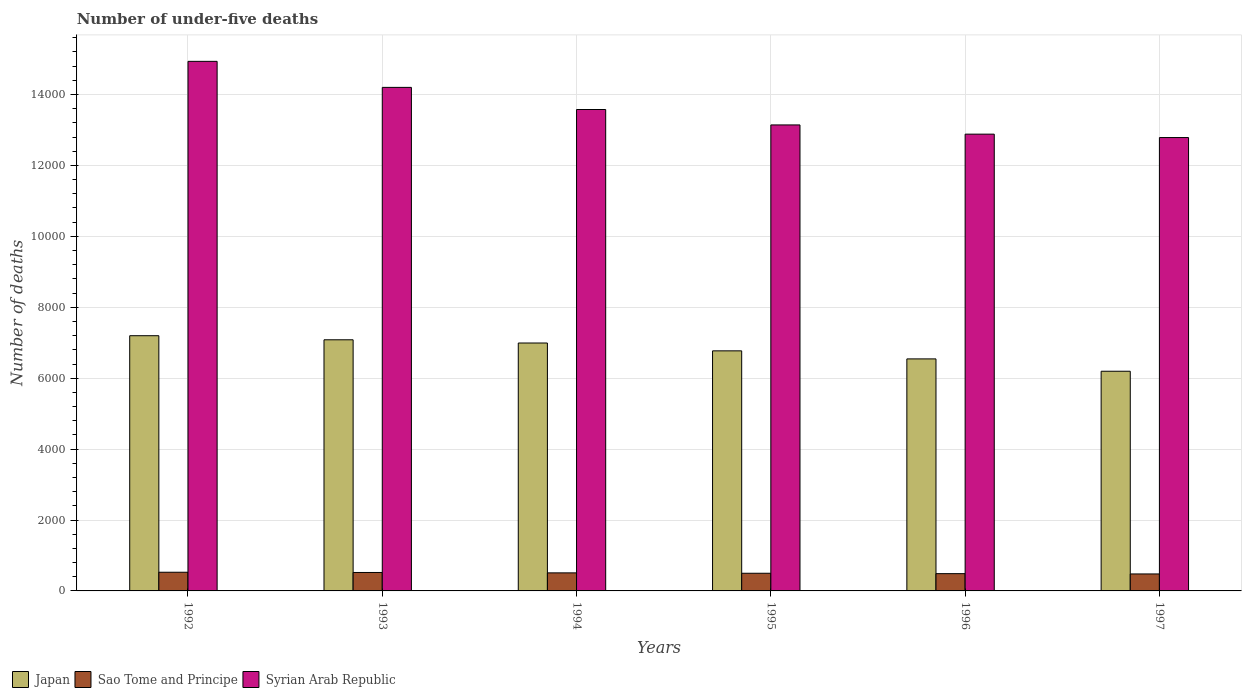Are the number of bars per tick equal to the number of legend labels?
Keep it short and to the point. Yes. Are the number of bars on each tick of the X-axis equal?
Your answer should be compact. Yes. What is the label of the 4th group of bars from the left?
Your answer should be compact. 1995. In how many cases, is the number of bars for a given year not equal to the number of legend labels?
Offer a very short reply. 0. What is the number of under-five deaths in Syrian Arab Republic in 1994?
Your answer should be compact. 1.36e+04. Across all years, what is the maximum number of under-five deaths in Japan?
Your answer should be compact. 7198. Across all years, what is the minimum number of under-five deaths in Syrian Arab Republic?
Provide a succinct answer. 1.28e+04. In which year was the number of under-five deaths in Syrian Arab Republic maximum?
Offer a terse response. 1992. What is the total number of under-five deaths in Sao Tome and Principe in the graph?
Give a very brief answer. 3020. What is the difference between the number of under-five deaths in Japan in 1992 and the number of under-five deaths in Syrian Arab Republic in 1996?
Keep it short and to the point. -5685. What is the average number of under-five deaths in Japan per year?
Give a very brief answer. 6797.33. In the year 1995, what is the difference between the number of under-five deaths in Sao Tome and Principe and number of under-five deaths in Japan?
Keep it short and to the point. -6273. In how many years, is the number of under-five deaths in Syrian Arab Republic greater than 14800?
Ensure brevity in your answer.  1. What is the ratio of the number of under-five deaths in Japan in 1992 to that in 1993?
Your answer should be very brief. 1.02. Is the difference between the number of under-five deaths in Sao Tome and Principe in 1994 and 1995 greater than the difference between the number of under-five deaths in Japan in 1994 and 1995?
Provide a short and direct response. No. What is the difference between the highest and the second highest number of under-five deaths in Syrian Arab Republic?
Your answer should be very brief. 734. What is the difference between the highest and the lowest number of under-five deaths in Syrian Arab Republic?
Give a very brief answer. 2149. In how many years, is the number of under-five deaths in Japan greater than the average number of under-five deaths in Japan taken over all years?
Offer a very short reply. 3. What does the 2nd bar from the left in 1995 represents?
Your answer should be very brief. Sao Tome and Principe. What does the 1st bar from the right in 1993 represents?
Your answer should be very brief. Syrian Arab Republic. What is the difference between two consecutive major ticks on the Y-axis?
Provide a succinct answer. 2000. Are the values on the major ticks of Y-axis written in scientific E-notation?
Keep it short and to the point. No. Does the graph contain any zero values?
Your answer should be very brief. No. Where does the legend appear in the graph?
Make the answer very short. Bottom left. How many legend labels are there?
Your answer should be compact. 3. How are the legend labels stacked?
Give a very brief answer. Horizontal. What is the title of the graph?
Your answer should be very brief. Number of under-five deaths. What is the label or title of the X-axis?
Provide a succinct answer. Years. What is the label or title of the Y-axis?
Your response must be concise. Number of deaths. What is the Number of deaths of Japan in 1992?
Give a very brief answer. 7198. What is the Number of deaths of Sao Tome and Principe in 1992?
Make the answer very short. 527. What is the Number of deaths in Syrian Arab Republic in 1992?
Provide a short and direct response. 1.49e+04. What is the Number of deaths of Japan in 1993?
Ensure brevity in your answer.  7083. What is the Number of deaths in Sao Tome and Principe in 1993?
Offer a terse response. 520. What is the Number of deaths of Syrian Arab Republic in 1993?
Offer a very short reply. 1.42e+04. What is the Number of deaths of Japan in 1994?
Your answer should be very brief. 6992. What is the Number of deaths of Sao Tome and Principe in 1994?
Ensure brevity in your answer.  509. What is the Number of deaths in Syrian Arab Republic in 1994?
Keep it short and to the point. 1.36e+04. What is the Number of deaths in Japan in 1995?
Provide a short and direct response. 6771. What is the Number of deaths in Sao Tome and Principe in 1995?
Your answer should be compact. 498. What is the Number of deaths of Syrian Arab Republic in 1995?
Provide a short and direct response. 1.31e+04. What is the Number of deaths in Japan in 1996?
Your answer should be very brief. 6544. What is the Number of deaths of Sao Tome and Principe in 1996?
Make the answer very short. 487. What is the Number of deaths of Syrian Arab Republic in 1996?
Offer a very short reply. 1.29e+04. What is the Number of deaths in Japan in 1997?
Keep it short and to the point. 6196. What is the Number of deaths of Sao Tome and Principe in 1997?
Keep it short and to the point. 479. What is the Number of deaths in Syrian Arab Republic in 1997?
Give a very brief answer. 1.28e+04. Across all years, what is the maximum Number of deaths of Japan?
Offer a terse response. 7198. Across all years, what is the maximum Number of deaths of Sao Tome and Principe?
Offer a very short reply. 527. Across all years, what is the maximum Number of deaths of Syrian Arab Republic?
Provide a succinct answer. 1.49e+04. Across all years, what is the minimum Number of deaths in Japan?
Ensure brevity in your answer.  6196. Across all years, what is the minimum Number of deaths of Sao Tome and Principe?
Offer a very short reply. 479. Across all years, what is the minimum Number of deaths of Syrian Arab Republic?
Keep it short and to the point. 1.28e+04. What is the total Number of deaths of Japan in the graph?
Your answer should be compact. 4.08e+04. What is the total Number of deaths of Sao Tome and Principe in the graph?
Offer a very short reply. 3020. What is the total Number of deaths of Syrian Arab Republic in the graph?
Provide a succinct answer. 8.15e+04. What is the difference between the Number of deaths in Japan in 1992 and that in 1993?
Your response must be concise. 115. What is the difference between the Number of deaths in Syrian Arab Republic in 1992 and that in 1993?
Keep it short and to the point. 734. What is the difference between the Number of deaths of Japan in 1992 and that in 1994?
Your answer should be very brief. 206. What is the difference between the Number of deaths of Syrian Arab Republic in 1992 and that in 1994?
Your response must be concise. 1358. What is the difference between the Number of deaths of Japan in 1992 and that in 1995?
Offer a very short reply. 427. What is the difference between the Number of deaths of Syrian Arab Republic in 1992 and that in 1995?
Ensure brevity in your answer.  1793. What is the difference between the Number of deaths in Japan in 1992 and that in 1996?
Offer a terse response. 654. What is the difference between the Number of deaths in Sao Tome and Principe in 1992 and that in 1996?
Keep it short and to the point. 40. What is the difference between the Number of deaths of Syrian Arab Republic in 1992 and that in 1996?
Your answer should be compact. 2053. What is the difference between the Number of deaths of Japan in 1992 and that in 1997?
Make the answer very short. 1002. What is the difference between the Number of deaths of Syrian Arab Republic in 1992 and that in 1997?
Offer a very short reply. 2149. What is the difference between the Number of deaths in Japan in 1993 and that in 1994?
Provide a succinct answer. 91. What is the difference between the Number of deaths of Sao Tome and Principe in 1993 and that in 1994?
Provide a succinct answer. 11. What is the difference between the Number of deaths of Syrian Arab Republic in 1993 and that in 1994?
Ensure brevity in your answer.  624. What is the difference between the Number of deaths of Japan in 1993 and that in 1995?
Your response must be concise. 312. What is the difference between the Number of deaths in Syrian Arab Republic in 1993 and that in 1995?
Offer a terse response. 1059. What is the difference between the Number of deaths of Japan in 1993 and that in 1996?
Give a very brief answer. 539. What is the difference between the Number of deaths in Sao Tome and Principe in 1993 and that in 1996?
Make the answer very short. 33. What is the difference between the Number of deaths in Syrian Arab Republic in 1993 and that in 1996?
Provide a succinct answer. 1319. What is the difference between the Number of deaths of Japan in 1993 and that in 1997?
Offer a terse response. 887. What is the difference between the Number of deaths of Sao Tome and Principe in 1993 and that in 1997?
Offer a very short reply. 41. What is the difference between the Number of deaths of Syrian Arab Republic in 1993 and that in 1997?
Keep it short and to the point. 1415. What is the difference between the Number of deaths in Japan in 1994 and that in 1995?
Make the answer very short. 221. What is the difference between the Number of deaths of Sao Tome and Principe in 1994 and that in 1995?
Give a very brief answer. 11. What is the difference between the Number of deaths of Syrian Arab Republic in 1994 and that in 1995?
Provide a short and direct response. 435. What is the difference between the Number of deaths of Japan in 1994 and that in 1996?
Your response must be concise. 448. What is the difference between the Number of deaths of Sao Tome and Principe in 1994 and that in 1996?
Provide a succinct answer. 22. What is the difference between the Number of deaths of Syrian Arab Republic in 1994 and that in 1996?
Give a very brief answer. 695. What is the difference between the Number of deaths in Japan in 1994 and that in 1997?
Give a very brief answer. 796. What is the difference between the Number of deaths of Syrian Arab Republic in 1994 and that in 1997?
Your response must be concise. 791. What is the difference between the Number of deaths in Japan in 1995 and that in 1996?
Your answer should be compact. 227. What is the difference between the Number of deaths of Sao Tome and Principe in 1995 and that in 1996?
Give a very brief answer. 11. What is the difference between the Number of deaths in Syrian Arab Republic in 1995 and that in 1996?
Your answer should be compact. 260. What is the difference between the Number of deaths of Japan in 1995 and that in 1997?
Keep it short and to the point. 575. What is the difference between the Number of deaths of Sao Tome and Principe in 1995 and that in 1997?
Your answer should be very brief. 19. What is the difference between the Number of deaths in Syrian Arab Republic in 1995 and that in 1997?
Keep it short and to the point. 356. What is the difference between the Number of deaths in Japan in 1996 and that in 1997?
Your answer should be very brief. 348. What is the difference between the Number of deaths of Sao Tome and Principe in 1996 and that in 1997?
Ensure brevity in your answer.  8. What is the difference between the Number of deaths of Syrian Arab Republic in 1996 and that in 1997?
Provide a succinct answer. 96. What is the difference between the Number of deaths of Japan in 1992 and the Number of deaths of Sao Tome and Principe in 1993?
Offer a very short reply. 6678. What is the difference between the Number of deaths in Japan in 1992 and the Number of deaths in Syrian Arab Republic in 1993?
Ensure brevity in your answer.  -7004. What is the difference between the Number of deaths in Sao Tome and Principe in 1992 and the Number of deaths in Syrian Arab Republic in 1993?
Provide a succinct answer. -1.37e+04. What is the difference between the Number of deaths in Japan in 1992 and the Number of deaths in Sao Tome and Principe in 1994?
Offer a very short reply. 6689. What is the difference between the Number of deaths in Japan in 1992 and the Number of deaths in Syrian Arab Republic in 1994?
Keep it short and to the point. -6380. What is the difference between the Number of deaths in Sao Tome and Principe in 1992 and the Number of deaths in Syrian Arab Republic in 1994?
Offer a very short reply. -1.31e+04. What is the difference between the Number of deaths in Japan in 1992 and the Number of deaths in Sao Tome and Principe in 1995?
Provide a succinct answer. 6700. What is the difference between the Number of deaths in Japan in 1992 and the Number of deaths in Syrian Arab Republic in 1995?
Provide a short and direct response. -5945. What is the difference between the Number of deaths of Sao Tome and Principe in 1992 and the Number of deaths of Syrian Arab Republic in 1995?
Your answer should be very brief. -1.26e+04. What is the difference between the Number of deaths in Japan in 1992 and the Number of deaths in Sao Tome and Principe in 1996?
Your response must be concise. 6711. What is the difference between the Number of deaths of Japan in 1992 and the Number of deaths of Syrian Arab Republic in 1996?
Provide a succinct answer. -5685. What is the difference between the Number of deaths in Sao Tome and Principe in 1992 and the Number of deaths in Syrian Arab Republic in 1996?
Ensure brevity in your answer.  -1.24e+04. What is the difference between the Number of deaths of Japan in 1992 and the Number of deaths of Sao Tome and Principe in 1997?
Your answer should be compact. 6719. What is the difference between the Number of deaths in Japan in 1992 and the Number of deaths in Syrian Arab Republic in 1997?
Keep it short and to the point. -5589. What is the difference between the Number of deaths in Sao Tome and Principe in 1992 and the Number of deaths in Syrian Arab Republic in 1997?
Provide a succinct answer. -1.23e+04. What is the difference between the Number of deaths in Japan in 1993 and the Number of deaths in Sao Tome and Principe in 1994?
Provide a succinct answer. 6574. What is the difference between the Number of deaths of Japan in 1993 and the Number of deaths of Syrian Arab Republic in 1994?
Make the answer very short. -6495. What is the difference between the Number of deaths in Sao Tome and Principe in 1993 and the Number of deaths in Syrian Arab Republic in 1994?
Provide a short and direct response. -1.31e+04. What is the difference between the Number of deaths in Japan in 1993 and the Number of deaths in Sao Tome and Principe in 1995?
Give a very brief answer. 6585. What is the difference between the Number of deaths of Japan in 1993 and the Number of deaths of Syrian Arab Republic in 1995?
Offer a terse response. -6060. What is the difference between the Number of deaths of Sao Tome and Principe in 1993 and the Number of deaths of Syrian Arab Republic in 1995?
Make the answer very short. -1.26e+04. What is the difference between the Number of deaths of Japan in 1993 and the Number of deaths of Sao Tome and Principe in 1996?
Your answer should be very brief. 6596. What is the difference between the Number of deaths in Japan in 1993 and the Number of deaths in Syrian Arab Republic in 1996?
Your answer should be very brief. -5800. What is the difference between the Number of deaths of Sao Tome and Principe in 1993 and the Number of deaths of Syrian Arab Republic in 1996?
Your answer should be compact. -1.24e+04. What is the difference between the Number of deaths of Japan in 1993 and the Number of deaths of Sao Tome and Principe in 1997?
Make the answer very short. 6604. What is the difference between the Number of deaths of Japan in 1993 and the Number of deaths of Syrian Arab Republic in 1997?
Offer a very short reply. -5704. What is the difference between the Number of deaths of Sao Tome and Principe in 1993 and the Number of deaths of Syrian Arab Republic in 1997?
Give a very brief answer. -1.23e+04. What is the difference between the Number of deaths in Japan in 1994 and the Number of deaths in Sao Tome and Principe in 1995?
Offer a very short reply. 6494. What is the difference between the Number of deaths in Japan in 1994 and the Number of deaths in Syrian Arab Republic in 1995?
Offer a terse response. -6151. What is the difference between the Number of deaths in Sao Tome and Principe in 1994 and the Number of deaths in Syrian Arab Republic in 1995?
Your answer should be very brief. -1.26e+04. What is the difference between the Number of deaths of Japan in 1994 and the Number of deaths of Sao Tome and Principe in 1996?
Offer a terse response. 6505. What is the difference between the Number of deaths of Japan in 1994 and the Number of deaths of Syrian Arab Republic in 1996?
Offer a very short reply. -5891. What is the difference between the Number of deaths of Sao Tome and Principe in 1994 and the Number of deaths of Syrian Arab Republic in 1996?
Keep it short and to the point. -1.24e+04. What is the difference between the Number of deaths in Japan in 1994 and the Number of deaths in Sao Tome and Principe in 1997?
Keep it short and to the point. 6513. What is the difference between the Number of deaths of Japan in 1994 and the Number of deaths of Syrian Arab Republic in 1997?
Offer a terse response. -5795. What is the difference between the Number of deaths of Sao Tome and Principe in 1994 and the Number of deaths of Syrian Arab Republic in 1997?
Your answer should be compact. -1.23e+04. What is the difference between the Number of deaths in Japan in 1995 and the Number of deaths in Sao Tome and Principe in 1996?
Offer a terse response. 6284. What is the difference between the Number of deaths in Japan in 1995 and the Number of deaths in Syrian Arab Republic in 1996?
Provide a succinct answer. -6112. What is the difference between the Number of deaths of Sao Tome and Principe in 1995 and the Number of deaths of Syrian Arab Republic in 1996?
Provide a short and direct response. -1.24e+04. What is the difference between the Number of deaths in Japan in 1995 and the Number of deaths in Sao Tome and Principe in 1997?
Your answer should be very brief. 6292. What is the difference between the Number of deaths in Japan in 1995 and the Number of deaths in Syrian Arab Republic in 1997?
Offer a terse response. -6016. What is the difference between the Number of deaths of Sao Tome and Principe in 1995 and the Number of deaths of Syrian Arab Republic in 1997?
Make the answer very short. -1.23e+04. What is the difference between the Number of deaths in Japan in 1996 and the Number of deaths in Sao Tome and Principe in 1997?
Your answer should be very brief. 6065. What is the difference between the Number of deaths of Japan in 1996 and the Number of deaths of Syrian Arab Republic in 1997?
Your answer should be very brief. -6243. What is the difference between the Number of deaths of Sao Tome and Principe in 1996 and the Number of deaths of Syrian Arab Republic in 1997?
Offer a terse response. -1.23e+04. What is the average Number of deaths in Japan per year?
Your response must be concise. 6797.33. What is the average Number of deaths in Sao Tome and Principe per year?
Your answer should be very brief. 503.33. What is the average Number of deaths in Syrian Arab Republic per year?
Provide a succinct answer. 1.36e+04. In the year 1992, what is the difference between the Number of deaths of Japan and Number of deaths of Sao Tome and Principe?
Your answer should be very brief. 6671. In the year 1992, what is the difference between the Number of deaths of Japan and Number of deaths of Syrian Arab Republic?
Your answer should be compact. -7738. In the year 1992, what is the difference between the Number of deaths in Sao Tome and Principe and Number of deaths in Syrian Arab Republic?
Offer a very short reply. -1.44e+04. In the year 1993, what is the difference between the Number of deaths of Japan and Number of deaths of Sao Tome and Principe?
Offer a terse response. 6563. In the year 1993, what is the difference between the Number of deaths in Japan and Number of deaths in Syrian Arab Republic?
Keep it short and to the point. -7119. In the year 1993, what is the difference between the Number of deaths of Sao Tome and Principe and Number of deaths of Syrian Arab Republic?
Ensure brevity in your answer.  -1.37e+04. In the year 1994, what is the difference between the Number of deaths in Japan and Number of deaths in Sao Tome and Principe?
Offer a very short reply. 6483. In the year 1994, what is the difference between the Number of deaths of Japan and Number of deaths of Syrian Arab Republic?
Provide a short and direct response. -6586. In the year 1994, what is the difference between the Number of deaths in Sao Tome and Principe and Number of deaths in Syrian Arab Republic?
Offer a terse response. -1.31e+04. In the year 1995, what is the difference between the Number of deaths in Japan and Number of deaths in Sao Tome and Principe?
Your answer should be compact. 6273. In the year 1995, what is the difference between the Number of deaths in Japan and Number of deaths in Syrian Arab Republic?
Keep it short and to the point. -6372. In the year 1995, what is the difference between the Number of deaths in Sao Tome and Principe and Number of deaths in Syrian Arab Republic?
Provide a short and direct response. -1.26e+04. In the year 1996, what is the difference between the Number of deaths of Japan and Number of deaths of Sao Tome and Principe?
Provide a succinct answer. 6057. In the year 1996, what is the difference between the Number of deaths in Japan and Number of deaths in Syrian Arab Republic?
Your answer should be compact. -6339. In the year 1996, what is the difference between the Number of deaths of Sao Tome and Principe and Number of deaths of Syrian Arab Republic?
Make the answer very short. -1.24e+04. In the year 1997, what is the difference between the Number of deaths of Japan and Number of deaths of Sao Tome and Principe?
Provide a succinct answer. 5717. In the year 1997, what is the difference between the Number of deaths of Japan and Number of deaths of Syrian Arab Republic?
Provide a short and direct response. -6591. In the year 1997, what is the difference between the Number of deaths in Sao Tome and Principe and Number of deaths in Syrian Arab Republic?
Ensure brevity in your answer.  -1.23e+04. What is the ratio of the Number of deaths of Japan in 1992 to that in 1993?
Keep it short and to the point. 1.02. What is the ratio of the Number of deaths of Sao Tome and Principe in 1992 to that in 1993?
Keep it short and to the point. 1.01. What is the ratio of the Number of deaths in Syrian Arab Republic in 1992 to that in 1993?
Give a very brief answer. 1.05. What is the ratio of the Number of deaths in Japan in 1992 to that in 1994?
Your answer should be compact. 1.03. What is the ratio of the Number of deaths in Sao Tome and Principe in 1992 to that in 1994?
Your response must be concise. 1.04. What is the ratio of the Number of deaths of Syrian Arab Republic in 1992 to that in 1994?
Your answer should be compact. 1.1. What is the ratio of the Number of deaths of Japan in 1992 to that in 1995?
Provide a succinct answer. 1.06. What is the ratio of the Number of deaths in Sao Tome and Principe in 1992 to that in 1995?
Your response must be concise. 1.06. What is the ratio of the Number of deaths in Syrian Arab Republic in 1992 to that in 1995?
Provide a succinct answer. 1.14. What is the ratio of the Number of deaths in Japan in 1992 to that in 1996?
Your response must be concise. 1.1. What is the ratio of the Number of deaths in Sao Tome and Principe in 1992 to that in 1996?
Give a very brief answer. 1.08. What is the ratio of the Number of deaths in Syrian Arab Republic in 1992 to that in 1996?
Provide a short and direct response. 1.16. What is the ratio of the Number of deaths of Japan in 1992 to that in 1997?
Your answer should be very brief. 1.16. What is the ratio of the Number of deaths in Sao Tome and Principe in 1992 to that in 1997?
Provide a short and direct response. 1.1. What is the ratio of the Number of deaths in Syrian Arab Republic in 1992 to that in 1997?
Keep it short and to the point. 1.17. What is the ratio of the Number of deaths of Japan in 1993 to that in 1994?
Provide a succinct answer. 1.01. What is the ratio of the Number of deaths in Sao Tome and Principe in 1993 to that in 1994?
Your answer should be compact. 1.02. What is the ratio of the Number of deaths of Syrian Arab Republic in 1993 to that in 1994?
Your answer should be compact. 1.05. What is the ratio of the Number of deaths in Japan in 1993 to that in 1995?
Ensure brevity in your answer.  1.05. What is the ratio of the Number of deaths in Sao Tome and Principe in 1993 to that in 1995?
Provide a short and direct response. 1.04. What is the ratio of the Number of deaths of Syrian Arab Republic in 1993 to that in 1995?
Provide a short and direct response. 1.08. What is the ratio of the Number of deaths in Japan in 1993 to that in 1996?
Your answer should be very brief. 1.08. What is the ratio of the Number of deaths of Sao Tome and Principe in 1993 to that in 1996?
Offer a very short reply. 1.07. What is the ratio of the Number of deaths of Syrian Arab Republic in 1993 to that in 1996?
Provide a short and direct response. 1.1. What is the ratio of the Number of deaths in Japan in 1993 to that in 1997?
Offer a terse response. 1.14. What is the ratio of the Number of deaths in Sao Tome and Principe in 1993 to that in 1997?
Your response must be concise. 1.09. What is the ratio of the Number of deaths in Syrian Arab Republic in 1993 to that in 1997?
Keep it short and to the point. 1.11. What is the ratio of the Number of deaths of Japan in 1994 to that in 1995?
Your answer should be compact. 1.03. What is the ratio of the Number of deaths of Sao Tome and Principe in 1994 to that in 1995?
Make the answer very short. 1.02. What is the ratio of the Number of deaths in Syrian Arab Republic in 1994 to that in 1995?
Keep it short and to the point. 1.03. What is the ratio of the Number of deaths in Japan in 1994 to that in 1996?
Offer a very short reply. 1.07. What is the ratio of the Number of deaths of Sao Tome and Principe in 1994 to that in 1996?
Offer a terse response. 1.05. What is the ratio of the Number of deaths of Syrian Arab Republic in 1994 to that in 1996?
Provide a succinct answer. 1.05. What is the ratio of the Number of deaths of Japan in 1994 to that in 1997?
Keep it short and to the point. 1.13. What is the ratio of the Number of deaths in Sao Tome and Principe in 1994 to that in 1997?
Provide a short and direct response. 1.06. What is the ratio of the Number of deaths in Syrian Arab Republic in 1994 to that in 1997?
Give a very brief answer. 1.06. What is the ratio of the Number of deaths of Japan in 1995 to that in 1996?
Your answer should be compact. 1.03. What is the ratio of the Number of deaths of Sao Tome and Principe in 1995 to that in 1996?
Keep it short and to the point. 1.02. What is the ratio of the Number of deaths in Syrian Arab Republic in 1995 to that in 1996?
Give a very brief answer. 1.02. What is the ratio of the Number of deaths of Japan in 1995 to that in 1997?
Provide a succinct answer. 1.09. What is the ratio of the Number of deaths of Sao Tome and Principe in 1995 to that in 1997?
Provide a succinct answer. 1.04. What is the ratio of the Number of deaths of Syrian Arab Republic in 1995 to that in 1997?
Your answer should be very brief. 1.03. What is the ratio of the Number of deaths of Japan in 1996 to that in 1997?
Keep it short and to the point. 1.06. What is the ratio of the Number of deaths of Sao Tome and Principe in 1996 to that in 1997?
Offer a terse response. 1.02. What is the ratio of the Number of deaths in Syrian Arab Republic in 1996 to that in 1997?
Offer a terse response. 1.01. What is the difference between the highest and the second highest Number of deaths in Japan?
Keep it short and to the point. 115. What is the difference between the highest and the second highest Number of deaths of Sao Tome and Principe?
Provide a succinct answer. 7. What is the difference between the highest and the second highest Number of deaths in Syrian Arab Republic?
Your answer should be compact. 734. What is the difference between the highest and the lowest Number of deaths in Japan?
Offer a very short reply. 1002. What is the difference between the highest and the lowest Number of deaths of Syrian Arab Republic?
Keep it short and to the point. 2149. 